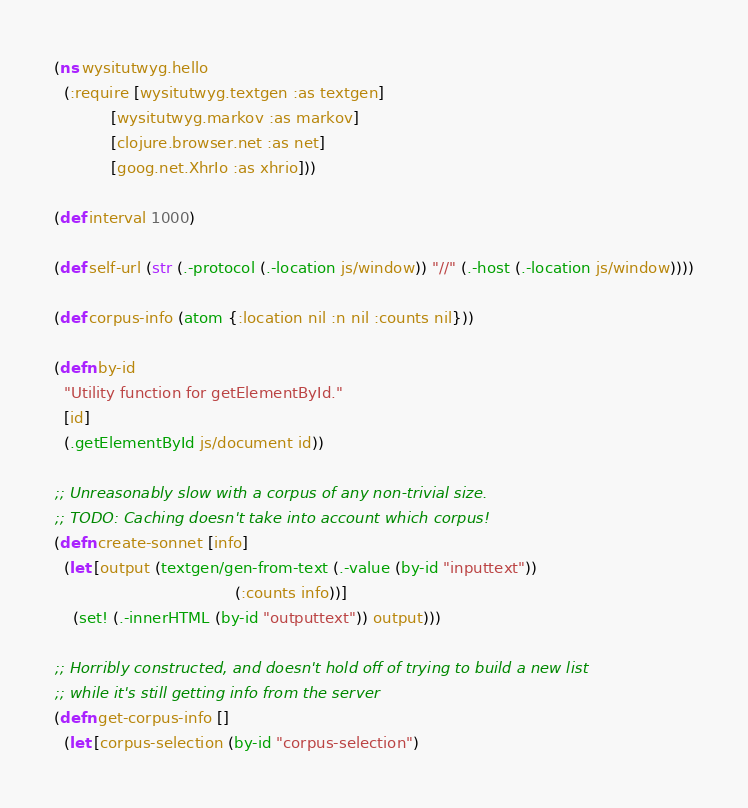<code> <loc_0><loc_0><loc_500><loc_500><_Clojure_>(ns wysitutwyg.hello
  (:require [wysitutwyg.textgen :as textgen]
            [wysitutwyg.markov :as markov]
            [clojure.browser.net :as net]
            [goog.net.XhrIo :as xhrio]))

(def interval 1000)

(def self-url (str (.-protocol (.-location js/window)) "//" (.-host (.-location js/window))))

(def corpus-info (atom {:location nil :n nil :counts nil}))

(defn by-id
  "Utility function for getElementById."
  [id]
  (.getElementById js/document id))
   
;; Unreasonably slow with a corpus of any non-trivial size.
;; TODO: Caching doesn't take into account which corpus!
(defn create-sonnet [info]
  (let [output (textgen/gen-from-text (.-value (by-id "inputtext"))
                                      (:counts info))]
    (set! (.-innerHTML (by-id "outputtext")) output)))

;; Horribly constructed, and doesn't hold off of trying to build a new list
;; while it's still getting info from the server
(defn get-corpus-info []
  (let [corpus-selection (by-id "corpus-selection")</code> 